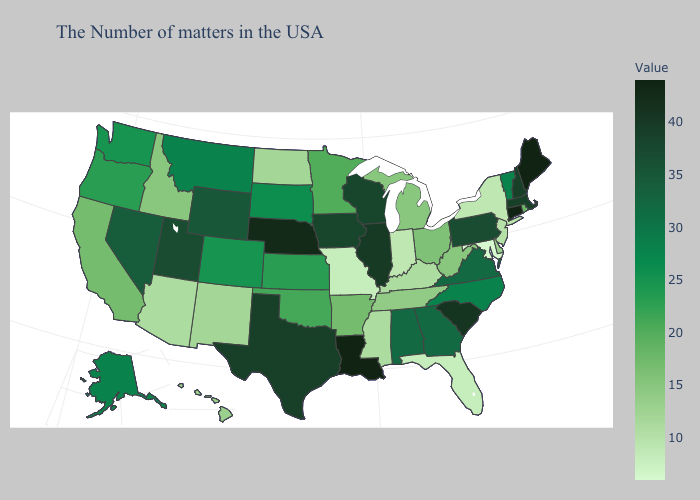Does the map have missing data?
Quick response, please. No. Among the states that border Arkansas , does Mississippi have the highest value?
Answer briefly. No. Among the states that border Massachusetts , does Vermont have the highest value?
Write a very short answer. No. Does Indiana have a lower value than California?
Concise answer only. Yes. Among the states that border Rhode Island , which have the highest value?
Quick response, please. Connecticut. Among the states that border Wyoming , which have the lowest value?
Concise answer only. Idaho. 